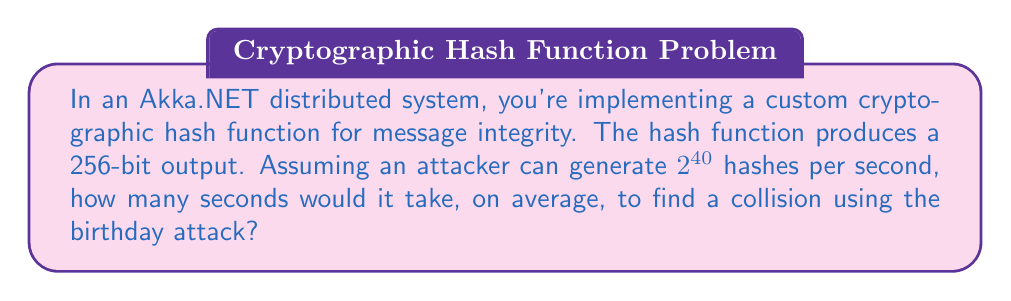Provide a solution to this math problem. Let's approach this step-by-step:

1) The birthday attack is based on the birthday paradox, which states that in a group of 23 people, there's a 50% chance that two people share the same birthday.

2) For a hash function with an n-bit output, the number of hashes needed to find a collision with 50% probability is approximately:

   $$\sqrt{2^n \cdot \ln(2)} \approx 1.177 \cdot 2^{n/2}$$

3) In our case, n = 256 bits. So, the number of hashes needed is:

   $$1.177 \cdot 2^{256/2} = 1.177 \cdot 2^{128} \approx 2^{128.23}$$

4) The attacker can generate $2^{40}$ hashes per second. To find the time in seconds, we divide the number of hashes needed by the hash rate:

   $$\frac{2^{128.23}}{2^{40}} = 2^{88.23}$$

5) To convert this to a decimal number:

   $$2^{88.23} \approx 3.94 \times 10^{26} \text{ seconds}$$

This is equivalent to about 1.25 × 10^19 years, far longer than the age of the universe!
Answer: $2^{88.23}$ seconds 